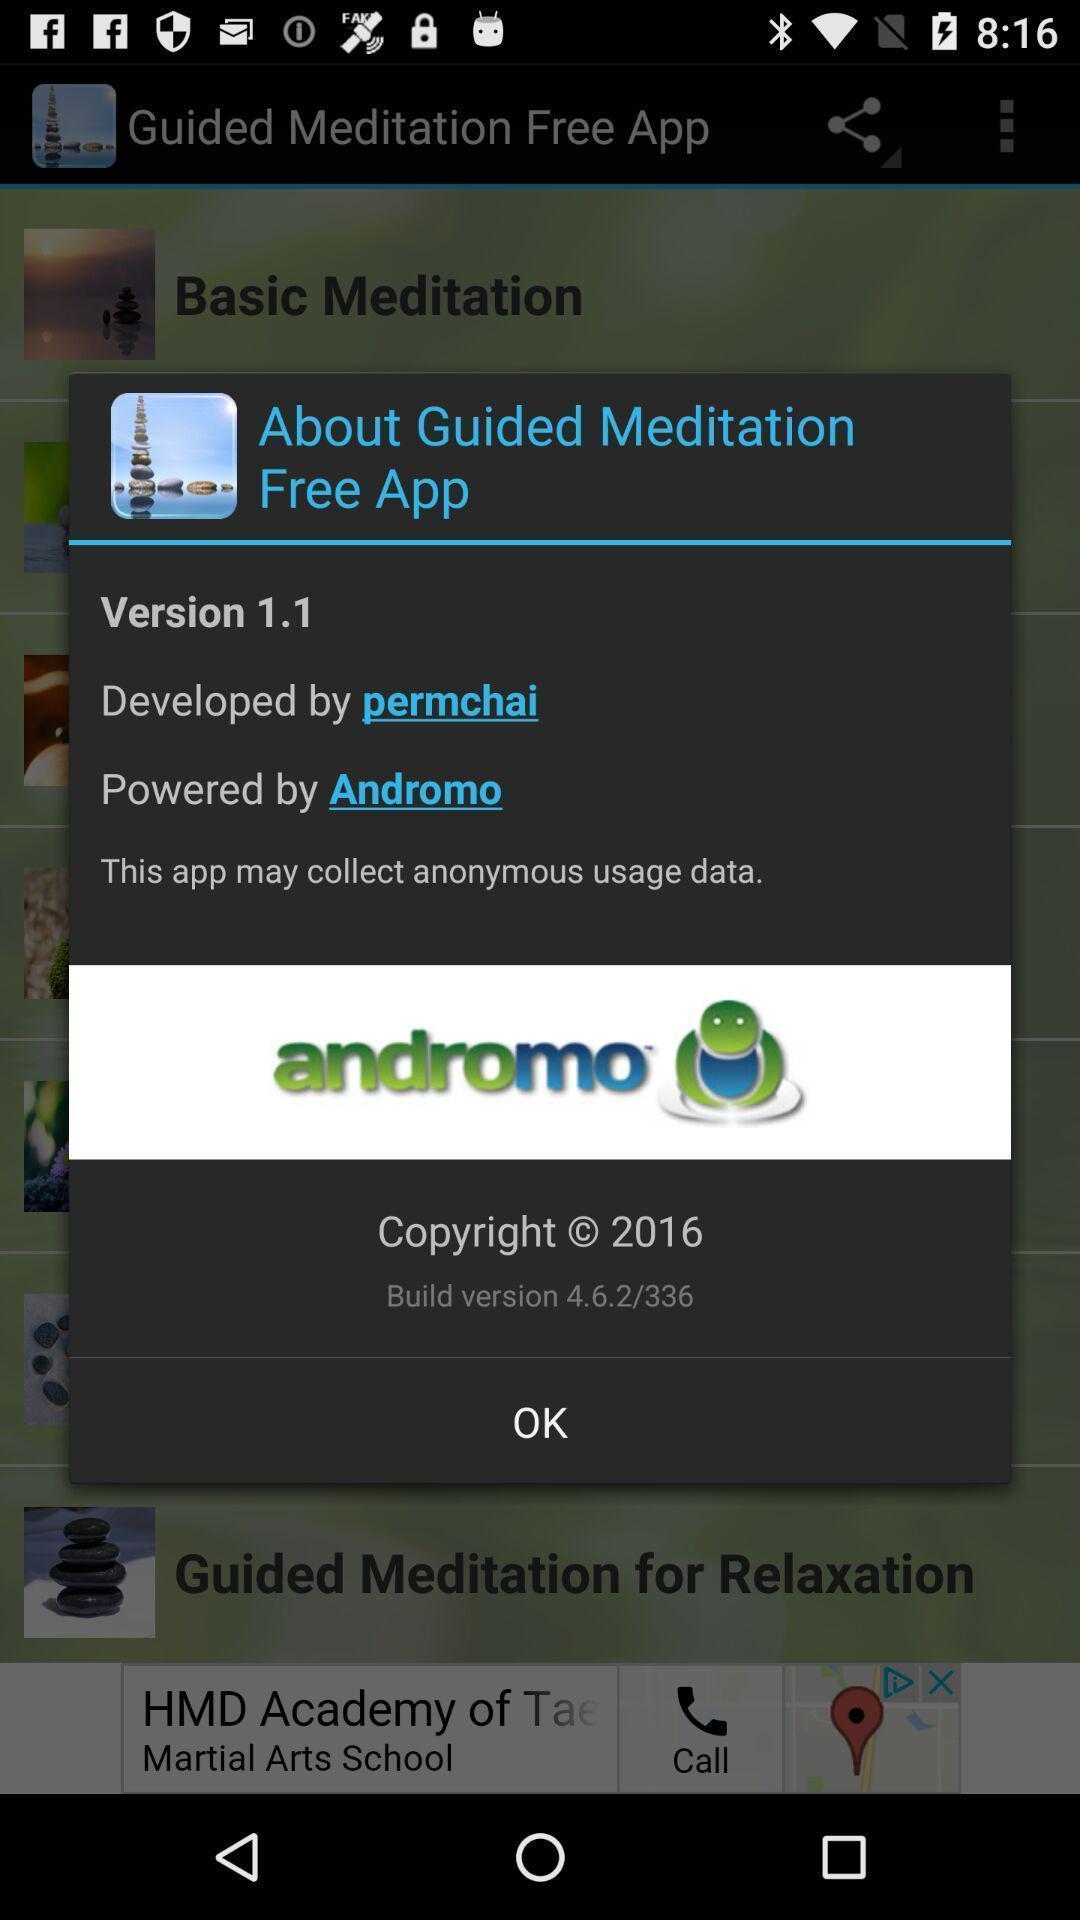What can you discern from this picture? Pop-up showing information about app. 